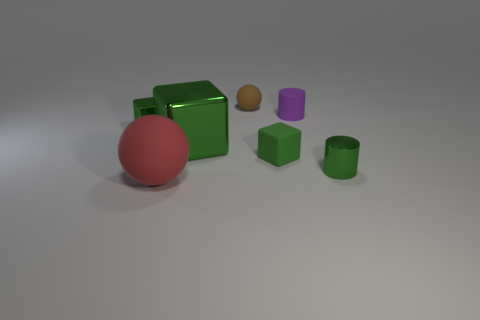How many tiny balls are there?
Make the answer very short. 1. What is the material of the big object that is behind the metal object on the right side of the small matte cube?
Your response must be concise. Metal. There is a purple object that is the same size as the green matte block; what is its material?
Give a very brief answer. Rubber. There is a green metallic thing that is on the right side of the brown thing; is its size the same as the big shiny block?
Offer a very short reply. No. There is a small green metallic object on the left side of the green rubber object; is its shape the same as the tiny purple object?
Your answer should be very brief. No. What number of objects are tiny brown matte spheres or tiny objects that are in front of the small shiny cube?
Your response must be concise. 3. Are there fewer small shiny objects than small blue balls?
Your response must be concise. No. Are there more small purple rubber objects than tiny red shiny things?
Your answer should be very brief. Yes. How many other objects are the same material as the big green block?
Your answer should be compact. 2. How many rubber spheres are behind the cylinder in front of the tiny green thing that is on the left side of the small matte block?
Provide a short and direct response. 1. 